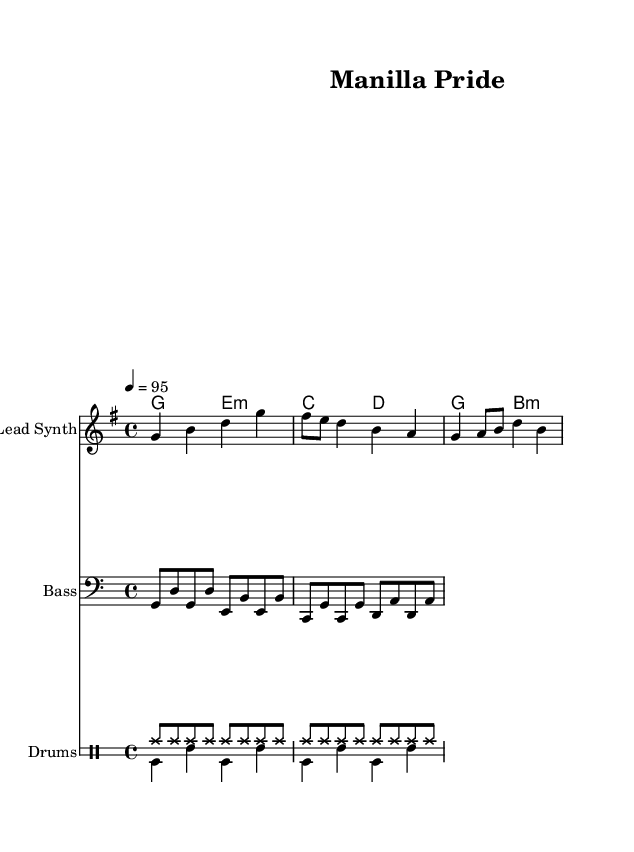What is the key signature of this music? The key signature is G major, which has one sharp (F#). This can be identified in the opening section of the sheet music where the key is stated, indicated by the note which contains an F# sharp on the staff.
Answer: G major What is the time signature of this music? The time signature is 4/4, meaning there are four beats in each measure and the quarter note gets one beat. This is indicated at the beginning of the score right after the key signature.
Answer: 4/4 What is the tempo marking for this piece? The tempo marking is 95 beats per minute, shown by "4 = 95" at the start of the score. This specifies the speed at which the piece should be played.
Answer: 95 How many measures are there in the melody section? The melody section contains a total of 3 measures, which can be counted by visually inspecting the melody line and identifying the separation of each measure.
Answer: 3 What instruments are featured in this score? The score features a Lead Synth, Bass, and Drums. This is indicated by the instrument names provided at the beginning of each staff in the score.
Answer: Lead Synth, Bass, Drums What type of drum pattern is mainly used in this piece? The drum pattern primarily uses a hi-hat pattern in eighth notes which contributes to the upbeat feel typical of hip hop music. This is identified in the "drumsUp" section of the drumming notation.
Answer: Hi-hat How does the harmony progression align with hip hop music conventions? The harmony progression is simple and includes basic chords (G, E minor, C, D) which is characteristic of hip hop. Hip hop frequently utilizes repetitive and straightforward chord progressions for lyrical flow.
Answer: Simple chord progression 